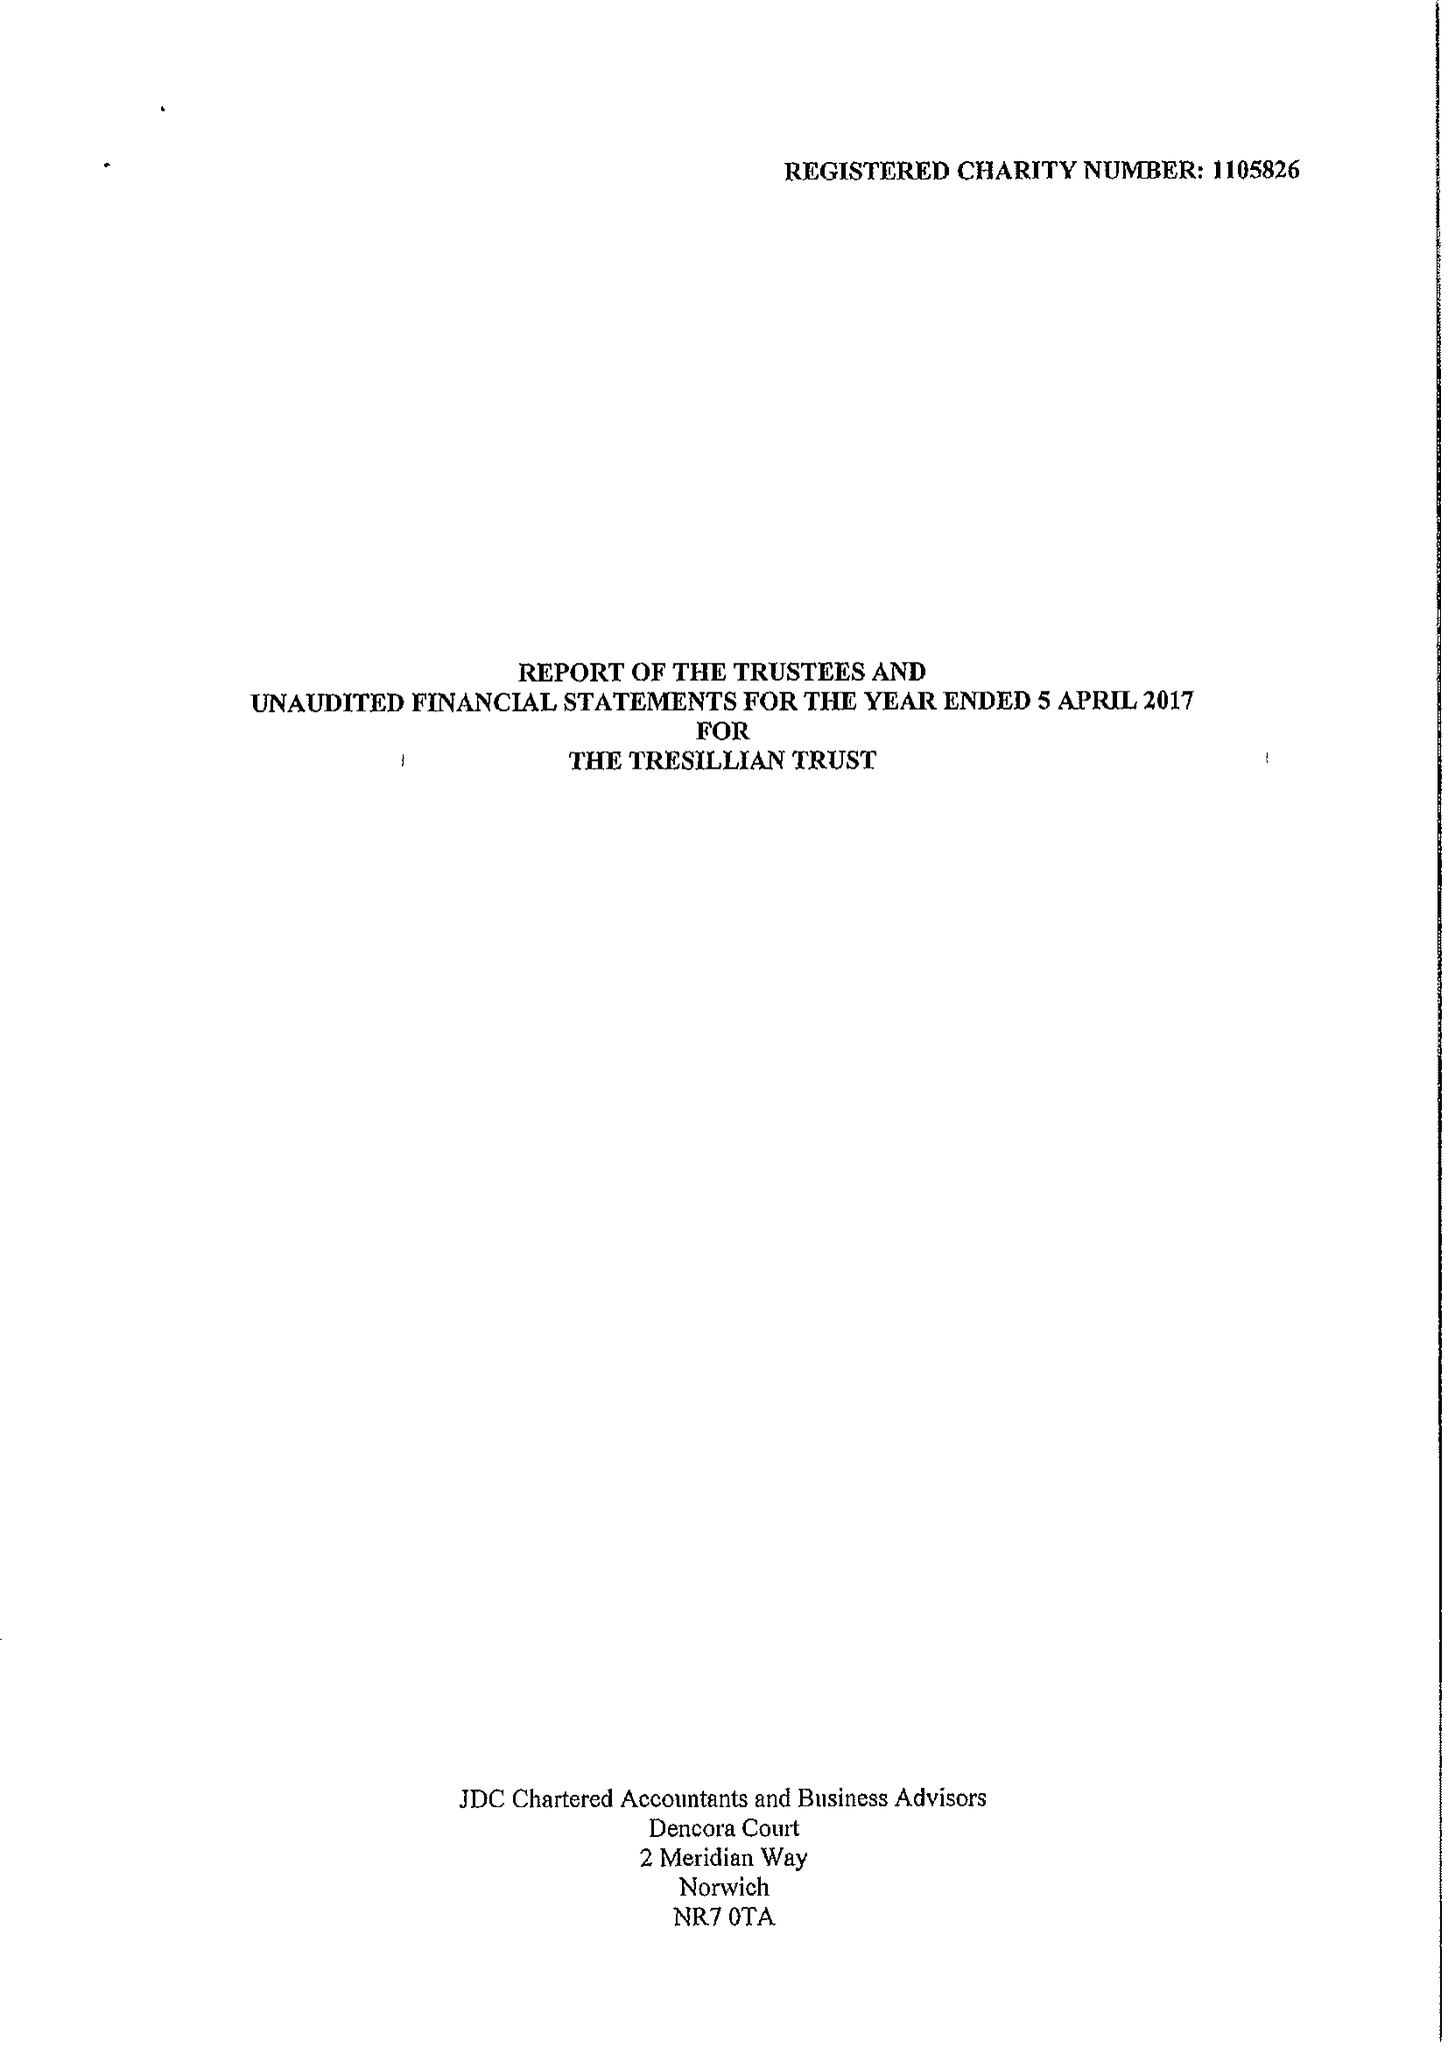What is the value for the address__street_line?
Answer the question using a single word or phrase. 20 VICTORIA STREET 